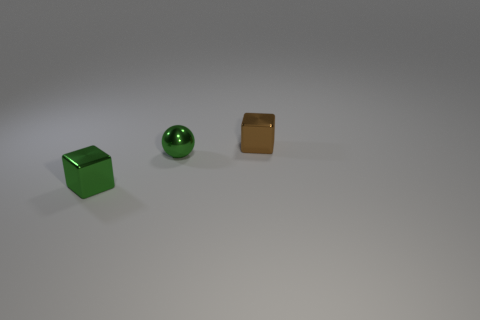Are there any other things that are the same shape as the small brown object?
Provide a succinct answer. Yes. There is a tiny brown shiny thing; what number of green cubes are on the right side of it?
Ensure brevity in your answer.  0. Are there an equal number of brown shiny cubes on the left side of the brown thing and blocks?
Your answer should be compact. No. Is the material of the small brown cube the same as the sphere?
Make the answer very short. Yes. How big is the shiny thing that is both to the left of the brown object and to the right of the green metal block?
Make the answer very short. Small. How many brown things have the same size as the green sphere?
Give a very brief answer. 1. There is a block that is to the right of the metallic block that is left of the brown metal thing; what is its size?
Offer a terse response. Small. There is a green thing behind the green cube; is it the same shape as the metal object behind the green shiny ball?
Provide a short and direct response. No. There is a tiny metal thing that is both in front of the brown metallic block and to the right of the green cube; what color is it?
Offer a terse response. Green. Is there a tiny block of the same color as the small shiny ball?
Make the answer very short. Yes. 